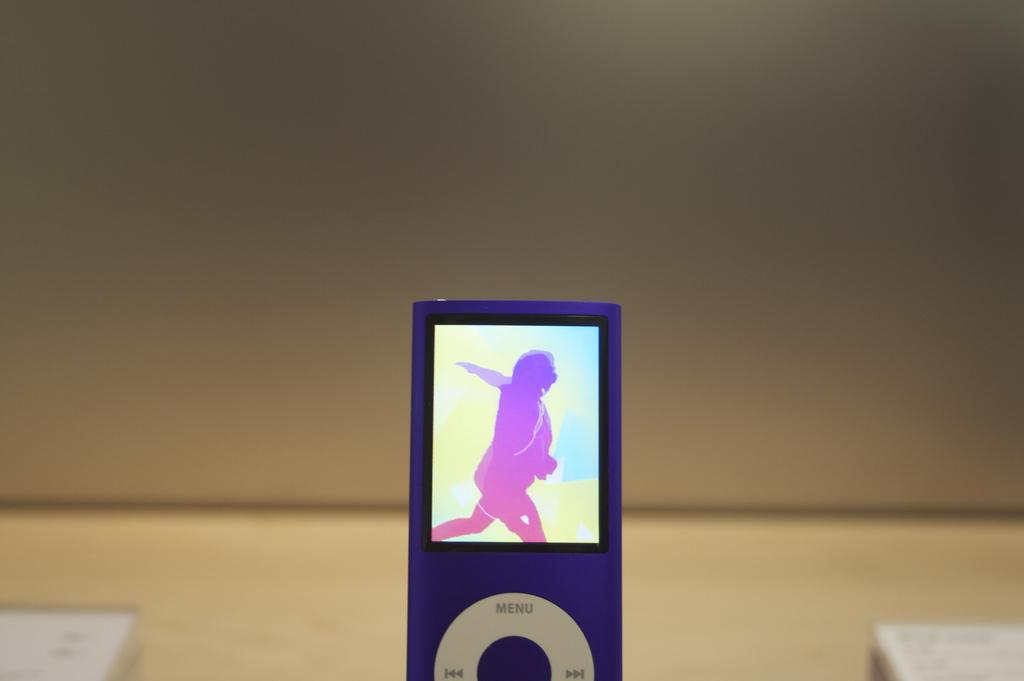What electronic device is visible in the image? There is an iPod in the image. What feature does the iPod have? The iPod has a screen. Can you describe the background of the image? The background of the image is blurred. What grade does the iPod receive for its performance in the image? The iPod's performance cannot be evaluated in the image, as it is an inanimate object and not a student. 